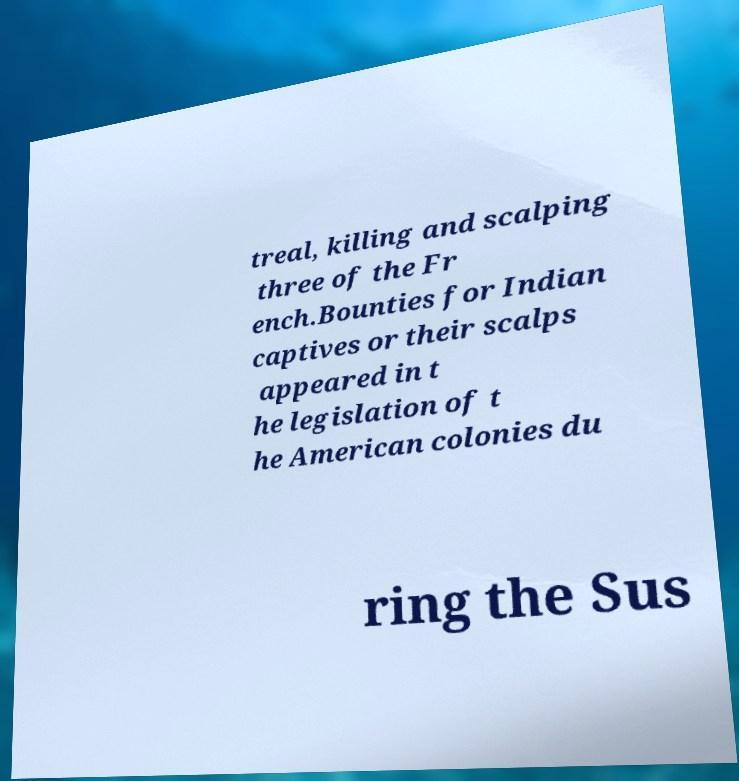What messages or text are displayed in this image? I need them in a readable, typed format. treal, killing and scalping three of the Fr ench.Bounties for Indian captives or their scalps appeared in t he legislation of t he American colonies du ring the Sus 